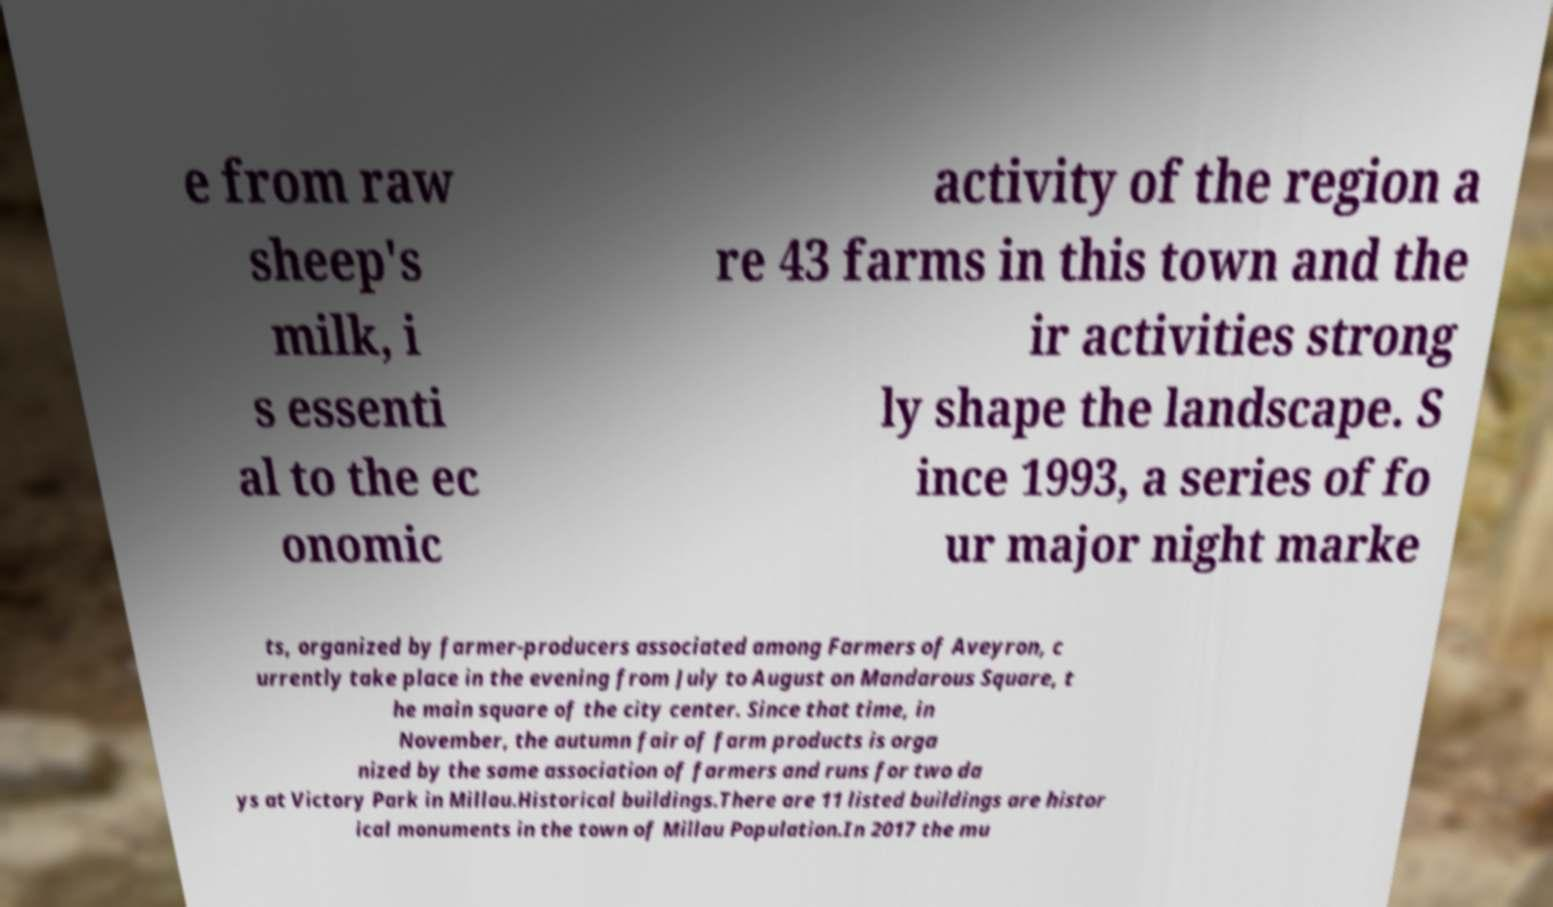Please read and relay the text visible in this image. What does it say? e from raw sheep's milk, i s essenti al to the ec onomic activity of the region a re 43 farms in this town and the ir activities strong ly shape the landscape. S ince 1993, a series of fo ur major night marke ts, organized by farmer-producers associated among Farmers of Aveyron, c urrently take place in the evening from July to August on Mandarous Square, t he main square of the city center. Since that time, in November, the autumn fair of farm products is orga nized by the same association of farmers and runs for two da ys at Victory Park in Millau.Historical buildings.There are 11 listed buildings are histor ical monuments in the town of Millau Population.In 2017 the mu 